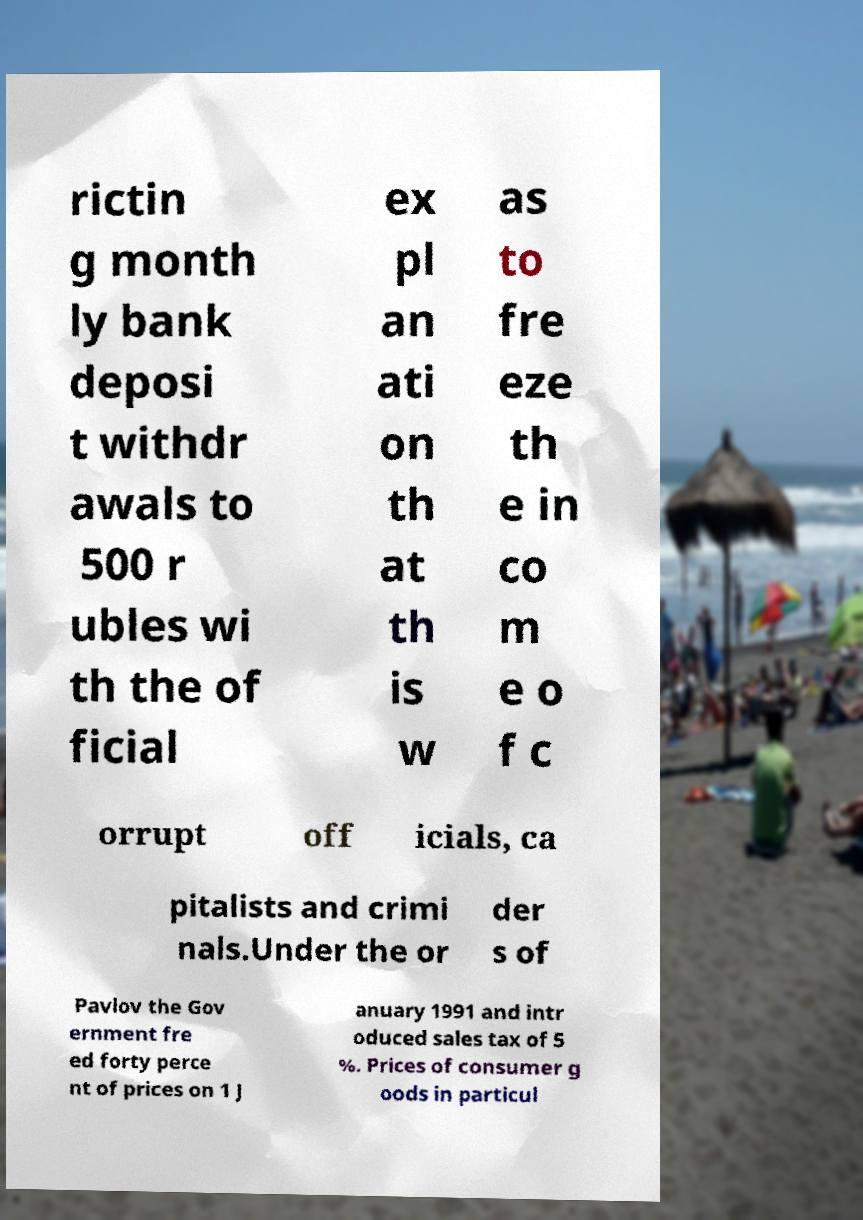Could you extract and type out the text from this image? rictin g month ly bank deposi t withdr awals to 500 r ubles wi th the of ficial ex pl an ati on th at th is w as to fre eze th e in co m e o f c orrupt off icials, ca pitalists and crimi nals.Under the or der s of Pavlov the Gov ernment fre ed forty perce nt of prices on 1 J anuary 1991 and intr oduced sales tax of 5 %. Prices of consumer g oods in particul 